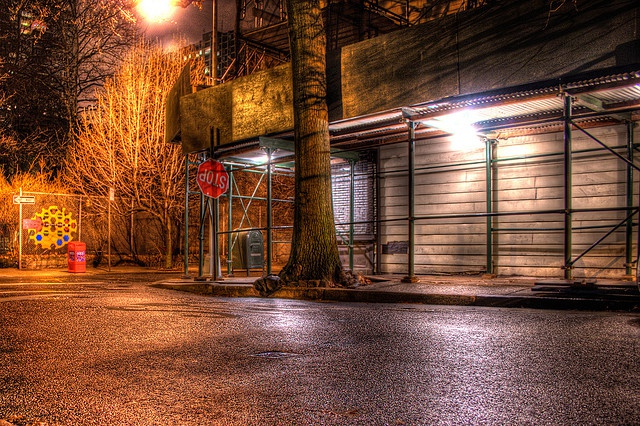Describe the objects in this image and their specific colors. I can see a stop sign in black, maroon, brown, and red tones in this image. 